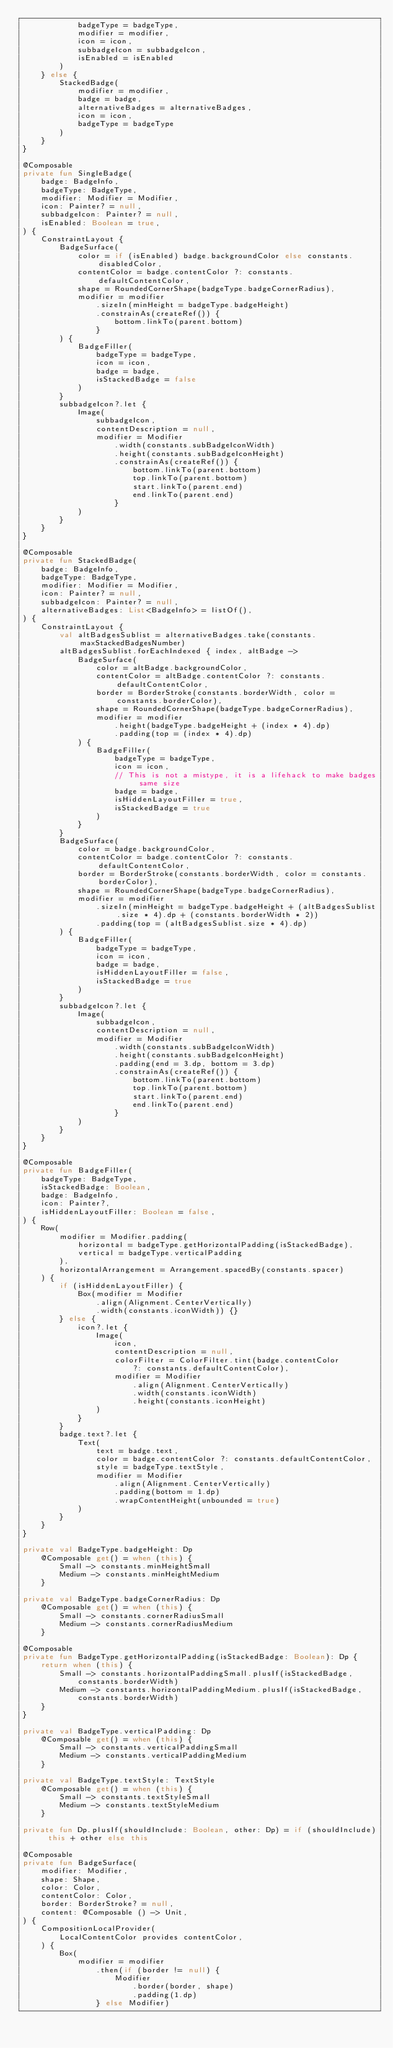Convert code to text. <code><loc_0><loc_0><loc_500><loc_500><_Kotlin_>            badgeType = badgeType,
            modifier = modifier,
            icon = icon,
            subbadgeIcon = subbadgeIcon,
            isEnabled = isEnabled
        )
    } else {
        StackedBadge(
            modifier = modifier,
            badge = badge,
            alternativeBadges = alternativeBadges,
            icon = icon,
            badgeType = badgeType
        )
    }
}

@Composable
private fun SingleBadge(
    badge: BadgeInfo,
    badgeType: BadgeType,
    modifier: Modifier = Modifier,
    icon: Painter? = null,
    subbadgeIcon: Painter? = null,
    isEnabled: Boolean = true,
) {
    ConstraintLayout {
        BadgeSurface(
            color = if (isEnabled) badge.backgroundColor else constants.disabledColor,
            contentColor = badge.contentColor ?: constants.defaultContentColor,
            shape = RoundedCornerShape(badgeType.badgeCornerRadius),
            modifier = modifier
                .sizeIn(minHeight = badgeType.badgeHeight)
                .constrainAs(createRef()) {
                    bottom.linkTo(parent.bottom)
                }
        ) {
            BadgeFiller(
                badgeType = badgeType,
                icon = icon,
                badge = badge,
                isStackedBadge = false
            )
        }
        subbadgeIcon?.let {
            Image(
                subbadgeIcon,
                contentDescription = null,
                modifier = Modifier
                    .width(constants.subBadgeIconWidth)
                    .height(constants.subBadgeIconHeight)
                    .constrainAs(createRef()) {
                        bottom.linkTo(parent.bottom)
                        top.linkTo(parent.bottom)
                        start.linkTo(parent.end)
                        end.linkTo(parent.end)
                    }
            )
        }
    }
}

@Composable
private fun StackedBadge(
    badge: BadgeInfo,
    badgeType: BadgeType,
    modifier: Modifier = Modifier,
    icon: Painter? = null,
    subbadgeIcon: Painter? = null,
    alternativeBadges: List<BadgeInfo> = listOf(),
) {
    ConstraintLayout {
        val altBadgesSublist = alternativeBadges.take(constants.maxStackedBadgesNumber)
        altBadgesSublist.forEachIndexed { index, altBadge ->
            BadgeSurface(
                color = altBadge.backgroundColor,
                contentColor = altBadge.contentColor ?: constants.defaultContentColor,
                border = BorderStroke(constants.borderWidth, color = constants.borderColor),
                shape = RoundedCornerShape(badgeType.badgeCornerRadius),
                modifier = modifier
                    .height(badgeType.badgeHeight + (index * 4).dp)
                    .padding(top = (index * 4).dp)
            ) {
                BadgeFiller(
                    badgeType = badgeType,
                    icon = icon,
                    // This is not a mistype, it is a lifehack to make badges same size
                    badge = badge,
                    isHiddenLayoutFiller = true,
                    isStackedBadge = true
                )
            }
        }
        BadgeSurface(
            color = badge.backgroundColor,
            contentColor = badge.contentColor ?: constants.defaultContentColor,
            border = BorderStroke(constants.borderWidth, color = constants.borderColor),
            shape = RoundedCornerShape(badgeType.badgeCornerRadius),
            modifier = modifier
                .sizeIn(minHeight = badgeType.badgeHeight + (altBadgesSublist.size * 4).dp + (constants.borderWidth * 2))
                .padding(top = (altBadgesSublist.size * 4).dp)
        ) {
            BadgeFiller(
                badgeType = badgeType,
                icon = icon,
                badge = badge,
                isHiddenLayoutFiller = false,
                isStackedBadge = true
            )
        }
        subbadgeIcon?.let {
            Image(
                subbadgeIcon,
                contentDescription = null,
                modifier = Modifier
                    .width(constants.subBadgeIconWidth)
                    .height(constants.subBadgeIconHeight)
                    .padding(end = 3.dp, bottom = 3.dp)
                    .constrainAs(createRef()) {
                        bottom.linkTo(parent.bottom)
                        top.linkTo(parent.bottom)
                        start.linkTo(parent.end)
                        end.linkTo(parent.end)
                    }
            )
        }
    }
}

@Composable
private fun BadgeFiller(
    badgeType: BadgeType,
    isStackedBadge: Boolean,
    badge: BadgeInfo,
    icon: Painter?,
    isHiddenLayoutFiller: Boolean = false,
) {
    Row(
        modifier = Modifier.padding(
            horizontal = badgeType.getHorizontalPadding(isStackedBadge),
            vertical = badgeType.verticalPadding
        ),
        horizontalArrangement = Arrangement.spacedBy(constants.spacer)
    ) {
        if (isHiddenLayoutFiller) {
            Box(modifier = Modifier
                .align(Alignment.CenterVertically)
                .width(constants.iconWidth)) {}
        } else {
            icon?.let {
                Image(
                    icon,
                    contentDescription = null,
                    colorFilter = ColorFilter.tint(badge.contentColor
                        ?: constants.defaultContentColor),
                    modifier = Modifier
                        .align(Alignment.CenterVertically)
                        .width(constants.iconWidth)
                        .height(constants.iconHeight)
                )
            }
        }
        badge.text?.let {
            Text(
                text = badge.text,
                color = badge.contentColor ?: constants.defaultContentColor,
                style = badgeType.textStyle,
                modifier = Modifier
                    .align(Alignment.CenterVertically)
                    .padding(bottom = 1.dp)
                    .wrapContentHeight(unbounded = true)
            )
        }
    }
}

private val BadgeType.badgeHeight: Dp
    @Composable get() = when (this) {
        Small -> constants.minHeightSmall
        Medium -> constants.minHeightMedium
    }

private val BadgeType.badgeCornerRadius: Dp
    @Composable get() = when (this) {
        Small -> constants.cornerRadiusSmall
        Medium -> constants.cornerRadiusMedium
    }

@Composable
private fun BadgeType.getHorizontalPadding(isStackedBadge: Boolean): Dp {
    return when (this) {
        Small -> constants.horizontalPaddingSmall.plusIf(isStackedBadge,
            constants.borderWidth)
        Medium -> constants.horizontalPaddingMedium.plusIf(isStackedBadge,
            constants.borderWidth)
    }
}

private val BadgeType.verticalPadding: Dp
    @Composable get() = when (this) {
        Small -> constants.verticalPaddingSmall
        Medium -> constants.verticalPaddingMedium
    }

private val BadgeType.textStyle: TextStyle
    @Composable get() = when (this) {
        Small -> constants.textStyleSmall
        Medium -> constants.textStyleMedium
    }

private fun Dp.plusIf(shouldInclude: Boolean, other: Dp) = if (shouldInclude) this + other else this

@Composable
private fun BadgeSurface(
    modifier: Modifier,
    shape: Shape,
    color: Color,
    contentColor: Color,
    border: BorderStroke? = null,
    content: @Composable () -> Unit,
) {
    CompositionLocalProvider(
        LocalContentColor provides contentColor,
    ) {
        Box(
            modifier = modifier
                .then(if (border != null) {
                    Modifier
                        .border(border, shape)
                        .padding(1.dp)
                } else Modifier)</code> 